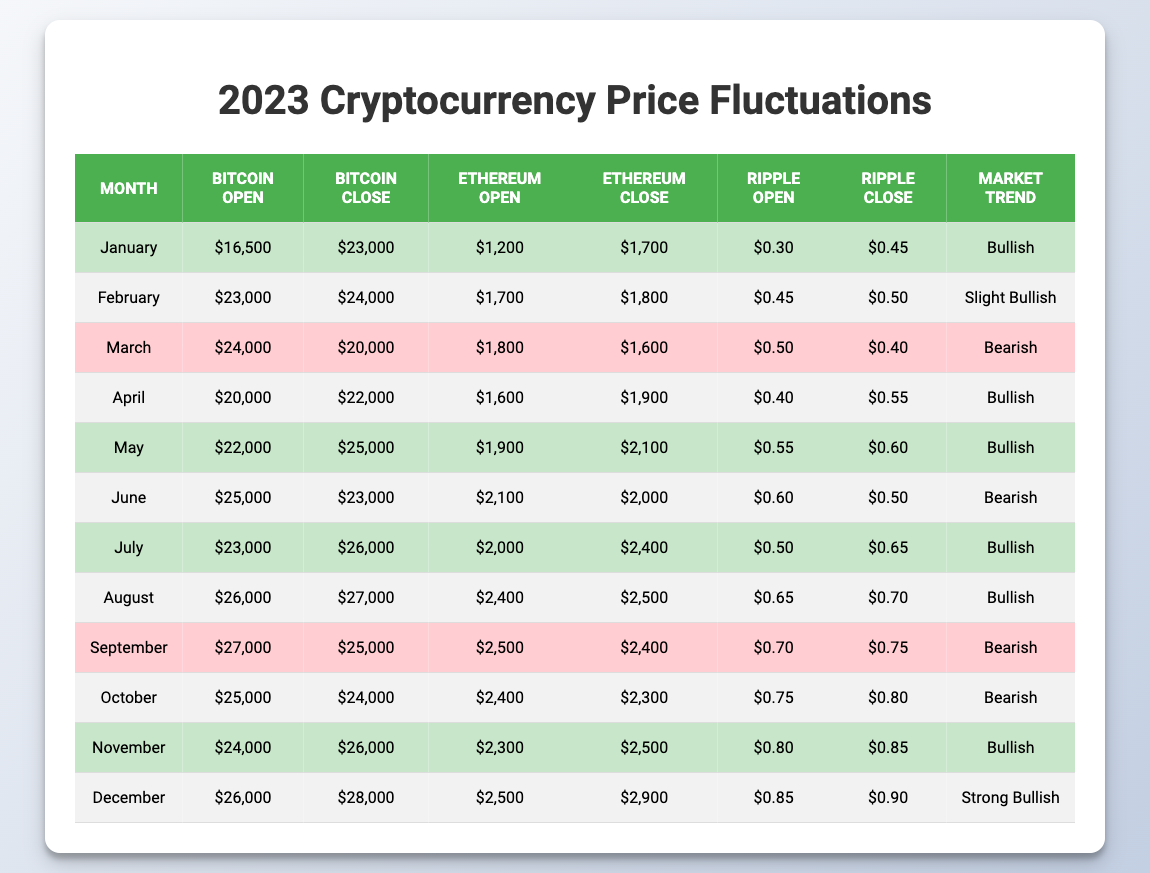What was the market trend for May? In the table, the trend for May is indicated in the "Market Trend" column. It shows "Bullish" for May.
Answer: Bullish Which month had the highest closing price for Bitcoin? The closing prices for Bitcoin are listed in the "Bitcoin Close" column. The highest closing price is $28,000 in December.
Answer: December What was the percentage increase in the closing price of Ethereum from January to February? The closing price of Ethereum in January is $1,700 and in February it is $1,800. The percentage increase is calculated as ((1800 - 1700) / 1700) * 100 = 5.88%.
Answer: 5.88% In which months did Ripple's closing price increase? To find this, compare the opening and closing prices of Ripple in each month. The months where the closing price is higher than the opening price are January, February, April, May, July, August, September, October, November, and December.
Answer: January, February, April, May, July, August, November, December What is the average opening price of Bitcoin for the first half of the year (January to June)? The opening prices for Bitcoin from January to June are $16,500, $23,000, $24,000, $20,000, $22,000, and $25,000. The sum of these prices is $130,500, and there are 6 months, so the average is 130,500 / 6 = $21,750.
Answer: $21,750 Was the market trend for July bullish? By checking the "Market Trend" column, July's trend is indicated as "Bullish."
Answer: Yes What was the difference between the opening and closing prices of Ethereum in March? In March, Ethereum's opening price is $1,800 and the closing price is $1,600. The difference is calculated as 1800 - 1600 = $200.
Answer: $200 List the months where Bitcoin's closing price dropped compared to its opening price? Check each month’s opening and closing prices. Bitcoin's closing price dropped in March, June, September, and October.
Answer: March, June, September, October What was the average closing price for Ripple in the second half of the year? The closing prices for Ripple in the second half (July to December) are $0.65, $0.70, $0.75, $0.80, $0.85, and $0.90, summing to $4.70. There are 6 months, so the average closing price is 4.70 / 6 = $0.7833.
Answer: $0.7833 Which month showed a "Strong Bullish" market trend? The "Market Trend" column indicates "Strong Bullish" for December.
Answer: December What is the total closing price change for Bitcoin from the beginning of the year to the end? Bitcoin's closing price was $23,000 in January and $28,000 in December. The total change is calculated as 28000 - 23000 = $5,000.
Answer: $5,000 